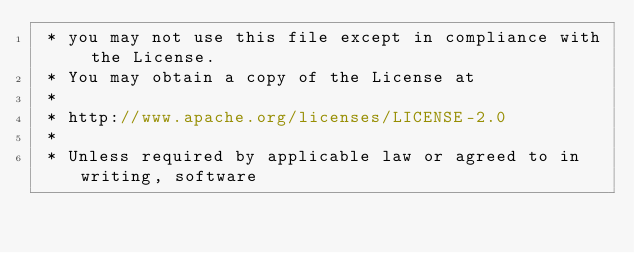Convert code to text. <code><loc_0><loc_0><loc_500><loc_500><_C_> * you may not use this file except in compliance with the License.
 * You may obtain a copy of the License at
 *
 * http://www.apache.org/licenses/LICENSE-2.0
 *
 * Unless required by applicable law or agreed to in writing, software</code> 